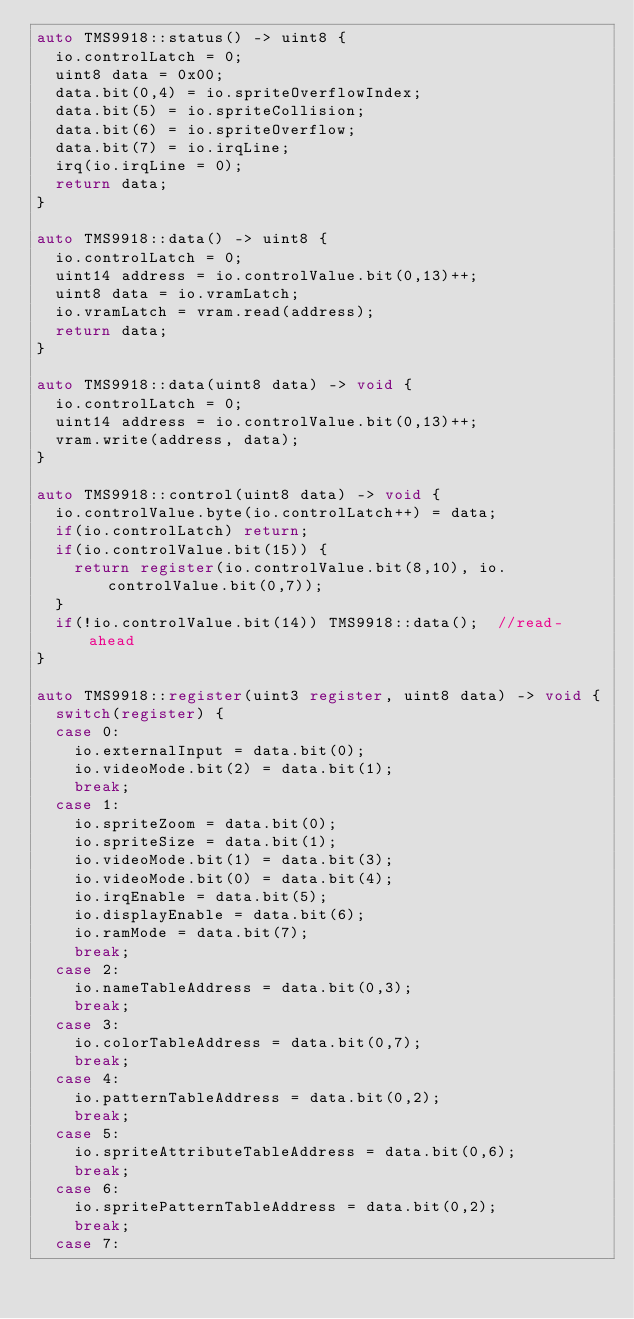Convert code to text. <code><loc_0><loc_0><loc_500><loc_500><_C++_>auto TMS9918::status() -> uint8 {
  io.controlLatch = 0;
  uint8 data = 0x00;
  data.bit(0,4) = io.spriteOverflowIndex;
  data.bit(5) = io.spriteCollision;
  data.bit(6) = io.spriteOverflow;
  data.bit(7) = io.irqLine;
  irq(io.irqLine = 0);
  return data;
}

auto TMS9918::data() -> uint8 {
  io.controlLatch = 0;
  uint14 address = io.controlValue.bit(0,13)++;
  uint8 data = io.vramLatch;
  io.vramLatch = vram.read(address);
  return data;
}

auto TMS9918::data(uint8 data) -> void {
  io.controlLatch = 0;
  uint14 address = io.controlValue.bit(0,13)++;
  vram.write(address, data);
}

auto TMS9918::control(uint8 data) -> void {
  io.controlValue.byte(io.controlLatch++) = data;
  if(io.controlLatch) return;
  if(io.controlValue.bit(15)) {
    return register(io.controlValue.bit(8,10), io.controlValue.bit(0,7));
  }
  if(!io.controlValue.bit(14)) TMS9918::data();  //read-ahead
}

auto TMS9918::register(uint3 register, uint8 data) -> void {
  switch(register) {
  case 0:
    io.externalInput = data.bit(0);
    io.videoMode.bit(2) = data.bit(1);
    break;
  case 1:
    io.spriteZoom = data.bit(0);
    io.spriteSize = data.bit(1);
    io.videoMode.bit(1) = data.bit(3);
    io.videoMode.bit(0) = data.bit(4);
    io.irqEnable = data.bit(5);
    io.displayEnable = data.bit(6);
    io.ramMode = data.bit(7);
    break;
  case 2:
    io.nameTableAddress = data.bit(0,3);
    break;
  case 3:
    io.colorTableAddress = data.bit(0,7);
    break;
  case 4:
    io.patternTableAddress = data.bit(0,2);
    break;
  case 5:
    io.spriteAttributeTableAddress = data.bit(0,6);
    break;
  case 6:
    io.spritePatternTableAddress = data.bit(0,2);
    break;
  case 7:</code> 